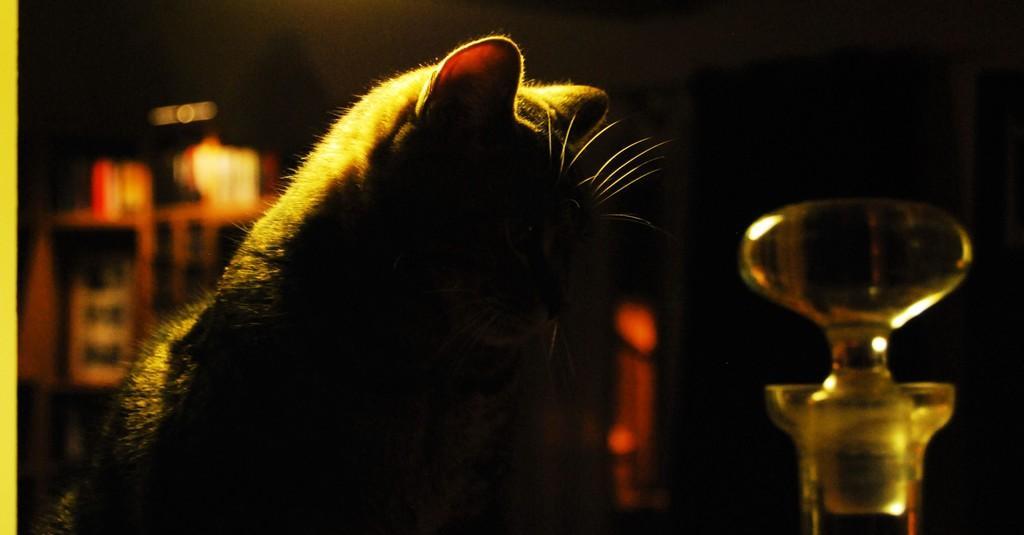Describe this image in one or two sentences. This image consists of a cat. On the right, there is a bottle. The background is too dark. 